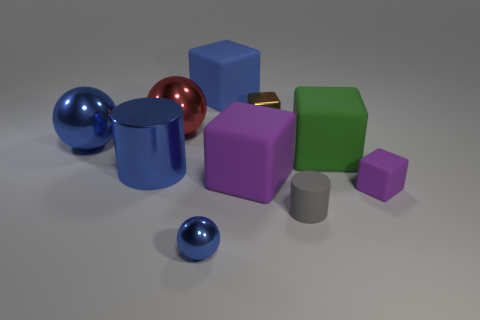Subtract all blue metal spheres. How many spheres are left? 1 Subtract all cylinders. How many objects are left? 8 Add 3 small brown shiny cubes. How many small brown shiny cubes exist? 4 Subtract all blue cylinders. How many cylinders are left? 1 Subtract 0 green spheres. How many objects are left? 10 Subtract 2 cubes. How many cubes are left? 3 Subtract all red cylinders. Subtract all gray spheres. How many cylinders are left? 2 Subtract all cyan blocks. How many gray cylinders are left? 1 Subtract all big brown shiny blocks. Subtract all matte blocks. How many objects are left? 6 Add 4 gray things. How many gray things are left? 5 